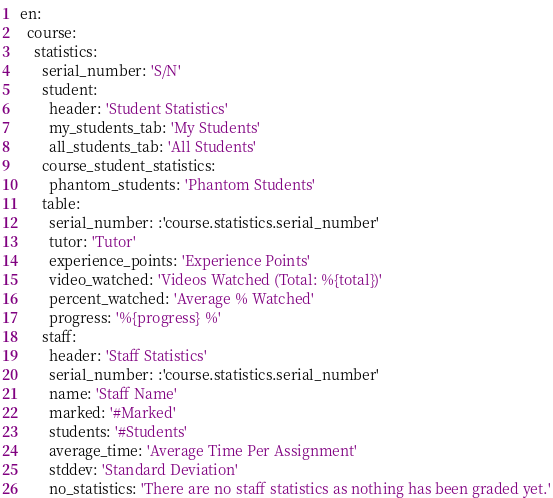Convert code to text. <code><loc_0><loc_0><loc_500><loc_500><_YAML_>en:
  course:
    statistics:
      serial_number: 'S/N'
      student:
        header: 'Student Statistics'
        my_students_tab: 'My Students'
        all_students_tab: 'All Students'
      course_student_statistics:
        phantom_students: 'Phantom Students'
      table:
        serial_number: :'course.statistics.serial_number'
        tutor: 'Tutor'
        experience_points: 'Experience Points'
        video_watched: 'Videos Watched (Total: %{total})'
        percent_watched: 'Average % Watched'
        progress: '%{progress} %'
      staff:
        header: 'Staff Statistics'
        serial_number: :'course.statistics.serial_number'
        name: 'Staff Name'
        marked: '#Marked'
        students: '#Students'
        average_time: 'Average Time Per Assignment'
        stddev: 'Standard Deviation'
        no_statistics: 'There are no staff statistics as nothing has been graded yet.'
</code> 